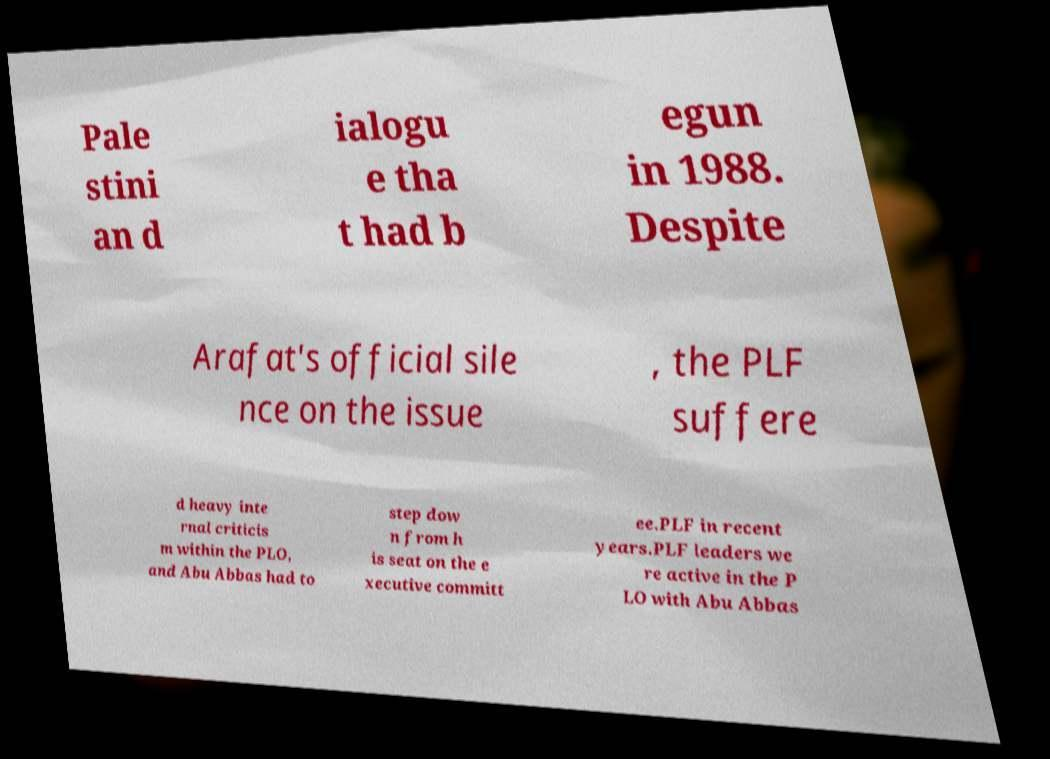There's text embedded in this image that I need extracted. Can you transcribe it verbatim? Pale stini an d ialogu e tha t had b egun in 1988. Despite Arafat's official sile nce on the issue , the PLF suffere d heavy inte rnal criticis m within the PLO, and Abu Abbas had to step dow n from h is seat on the e xecutive committ ee.PLF in recent years.PLF leaders we re active in the P LO with Abu Abbas 